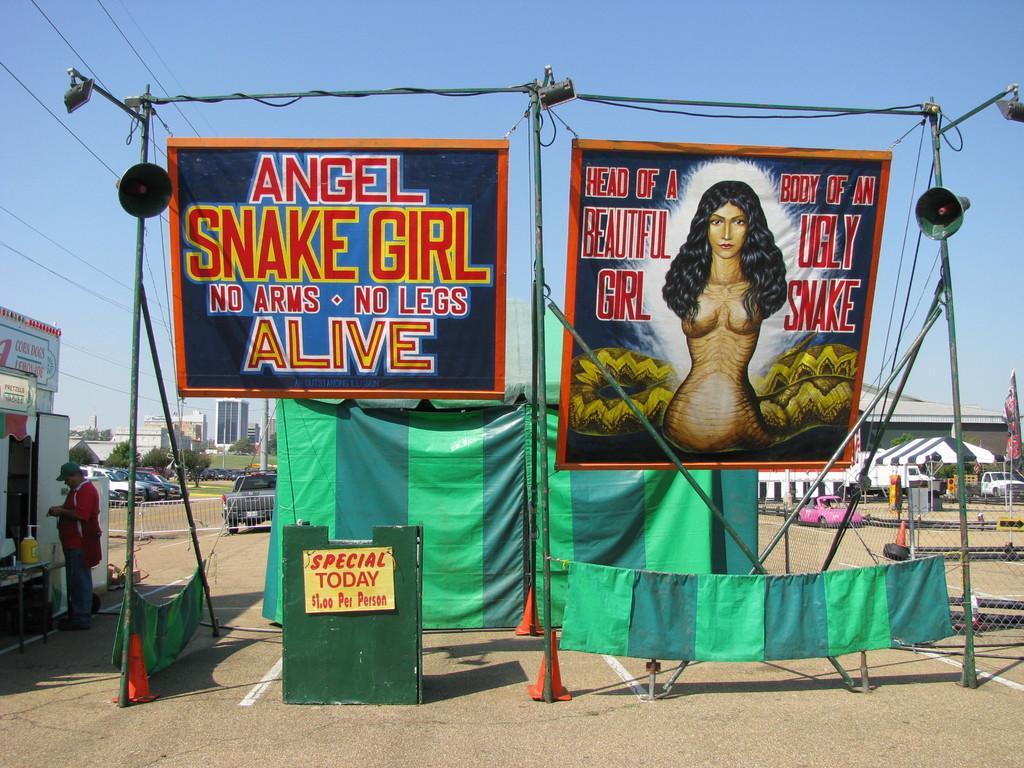Please provide a concise description of this image. In this picture I see 2 banners on which there is something written and I see a depiction of a woman on the right banner and I see the clothes and on the ground I see few traffic cones and on the left side of this image I see a man who is standing. In the background I see the cars, trees and number of buildings and I see the sky and on the top left of this image I see the wires. 